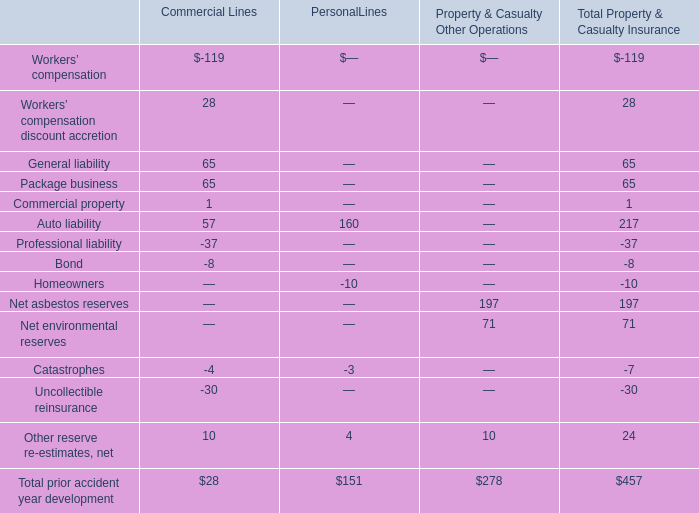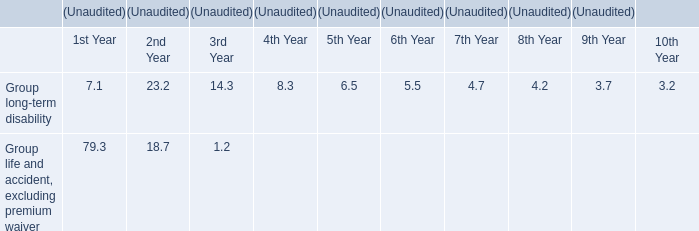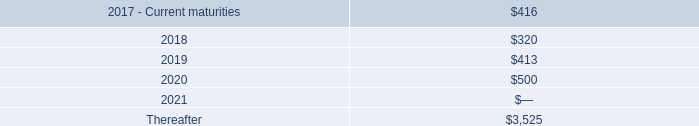What was the total amount of the Catastrophes in the sections where Auto liability greater than 0? 
Computations: (-4 - 3)
Answer: -7.0. 